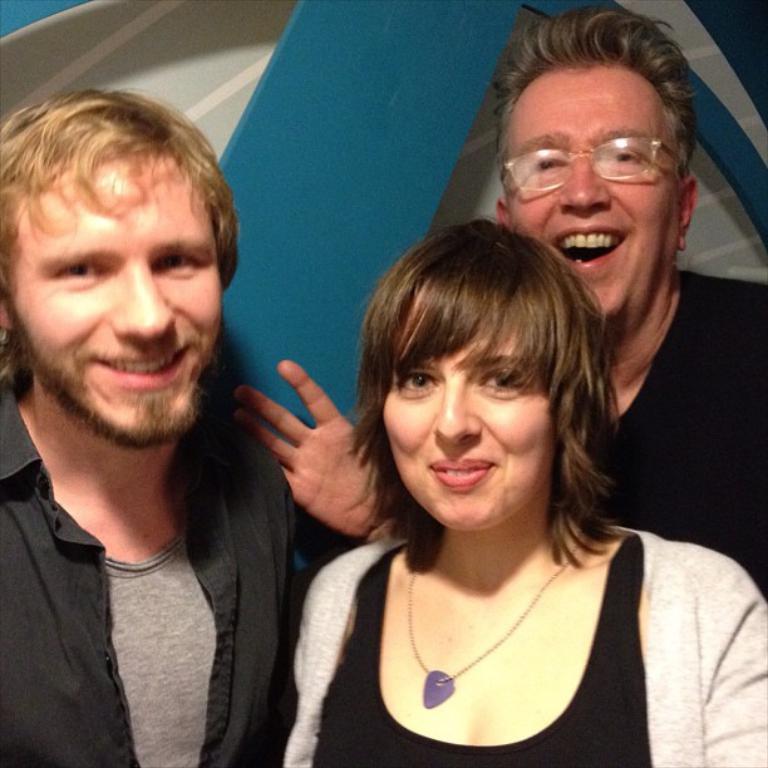Can you describe this image briefly? In the picture there are two men and a woman, they are smiling. In the background it is well. 